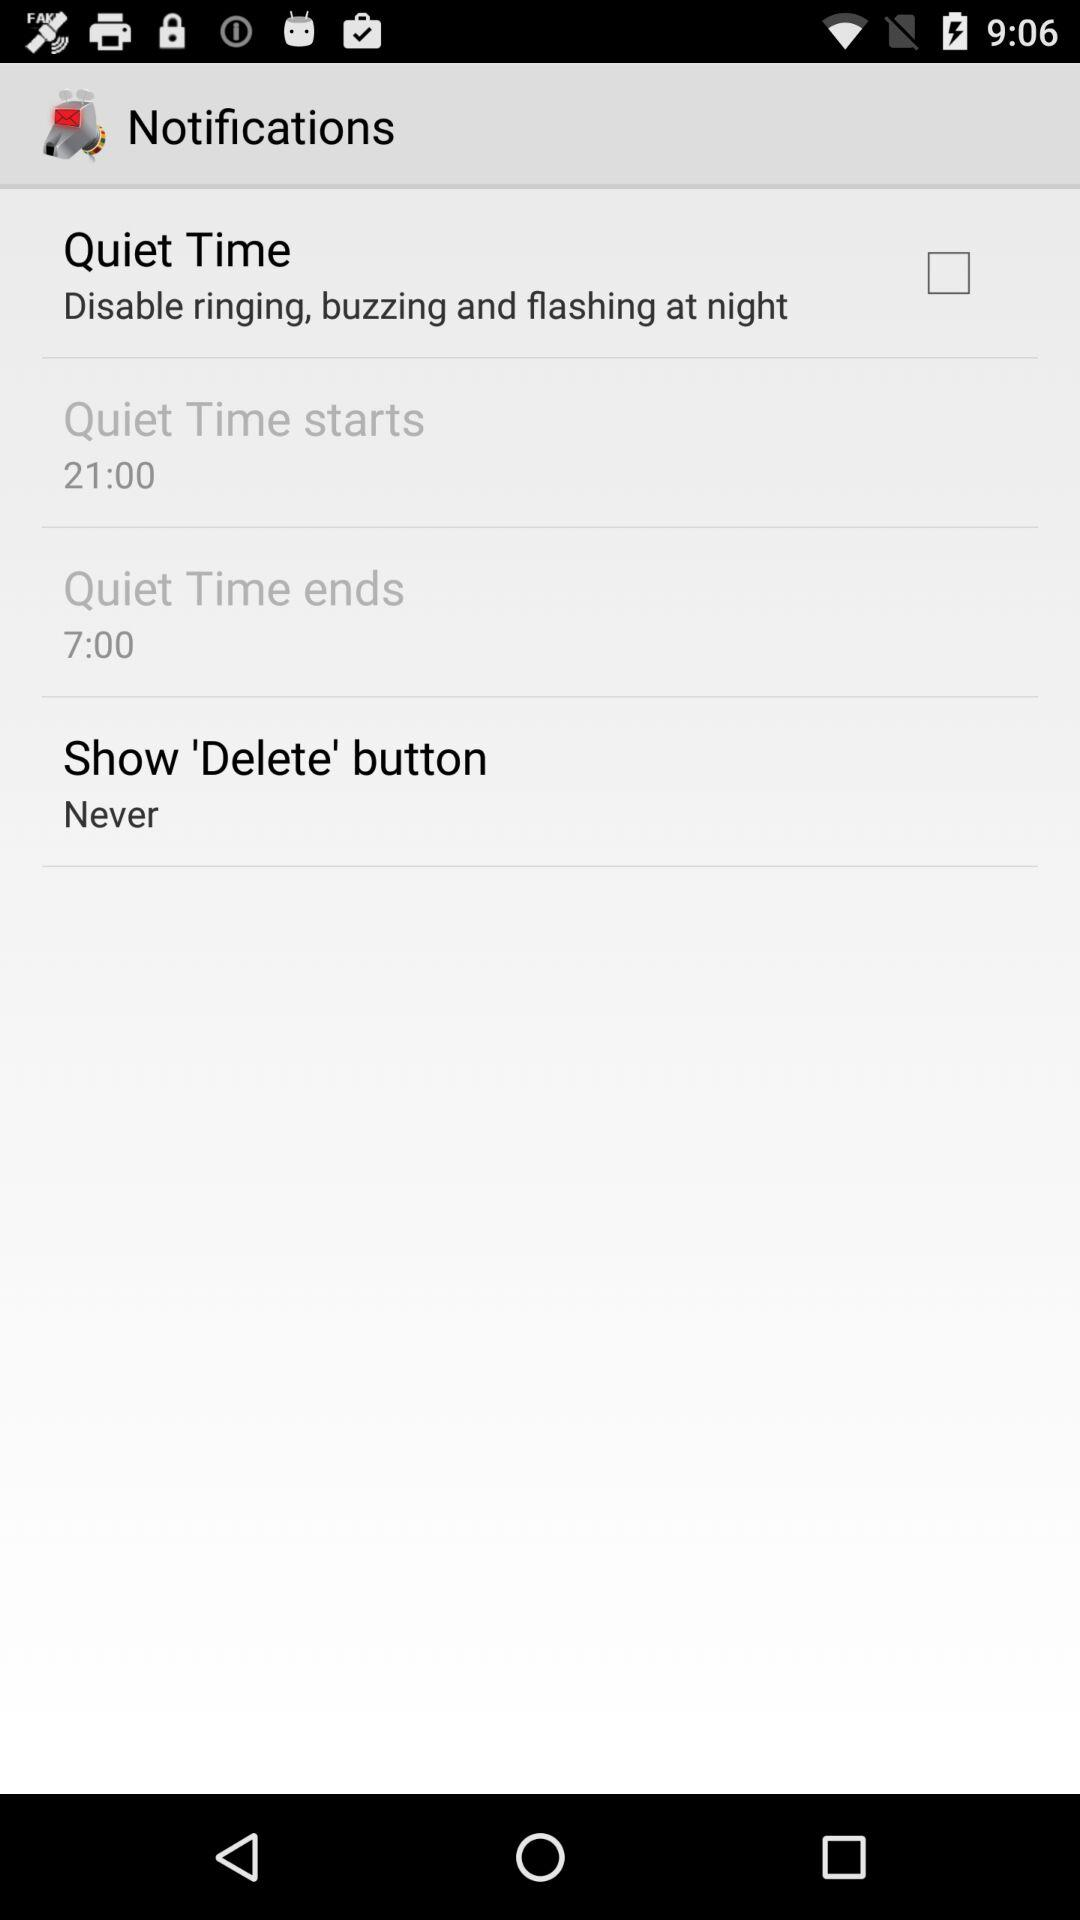What is the setting for the "Show 'Delete' button"? The setting for the "Show 'Delete' button" is "Never". 